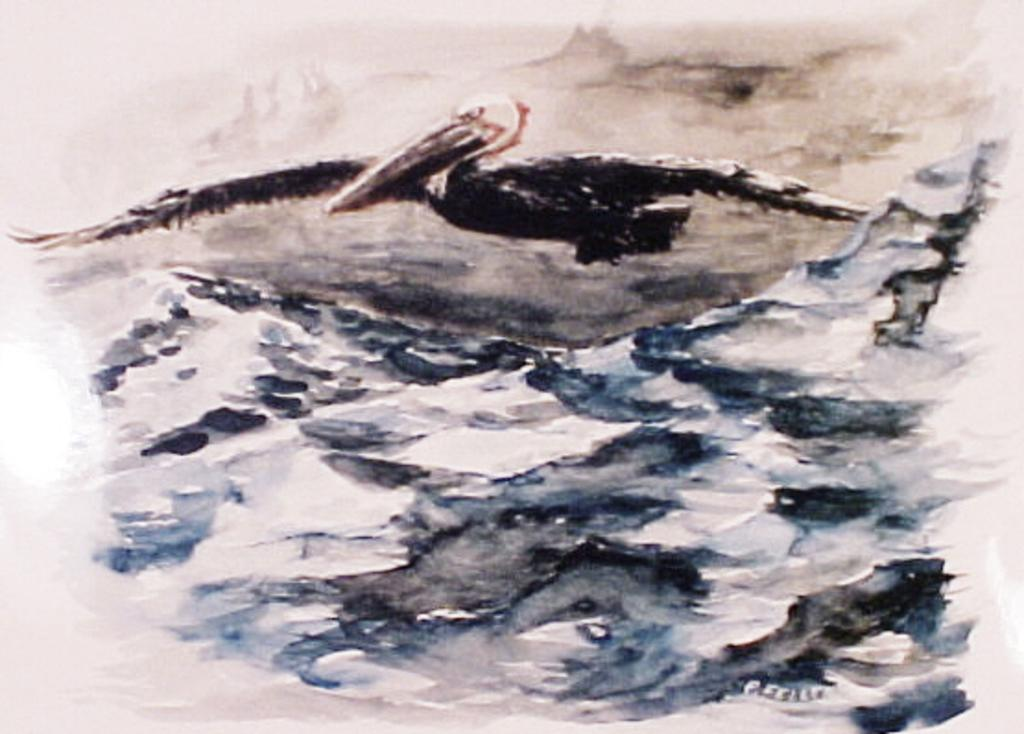What is the main subject of the image? The image contains a painting. What is the bird doing in the painting? The bird is flying in the sky in the painting. What type of landscape is depicted in the painting? There are mountains depicted in the painting. What can be seen in the background of the painting? The sky is visible in the background of the painting. What type of elbow can be seen in the painting? There is no elbow present in the painting; it features a bird flying in the sky and mountains. 